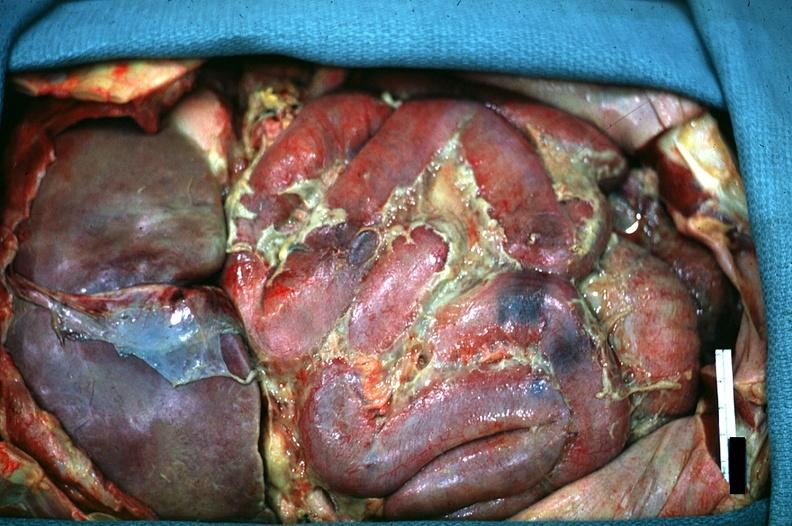what does this image show?
Answer the question using a single word or phrase. In situ of abdomen excellent fibrinopurulent peritonitis 